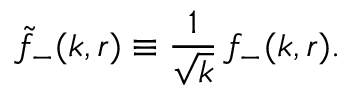Convert formula to latex. <formula><loc_0><loc_0><loc_500><loc_500>\tilde { f } _ { - } ( k , r ) \equiv \frac { 1 } { \sqrt { k } } \, f _ { - } ( k , r ) .</formula> 